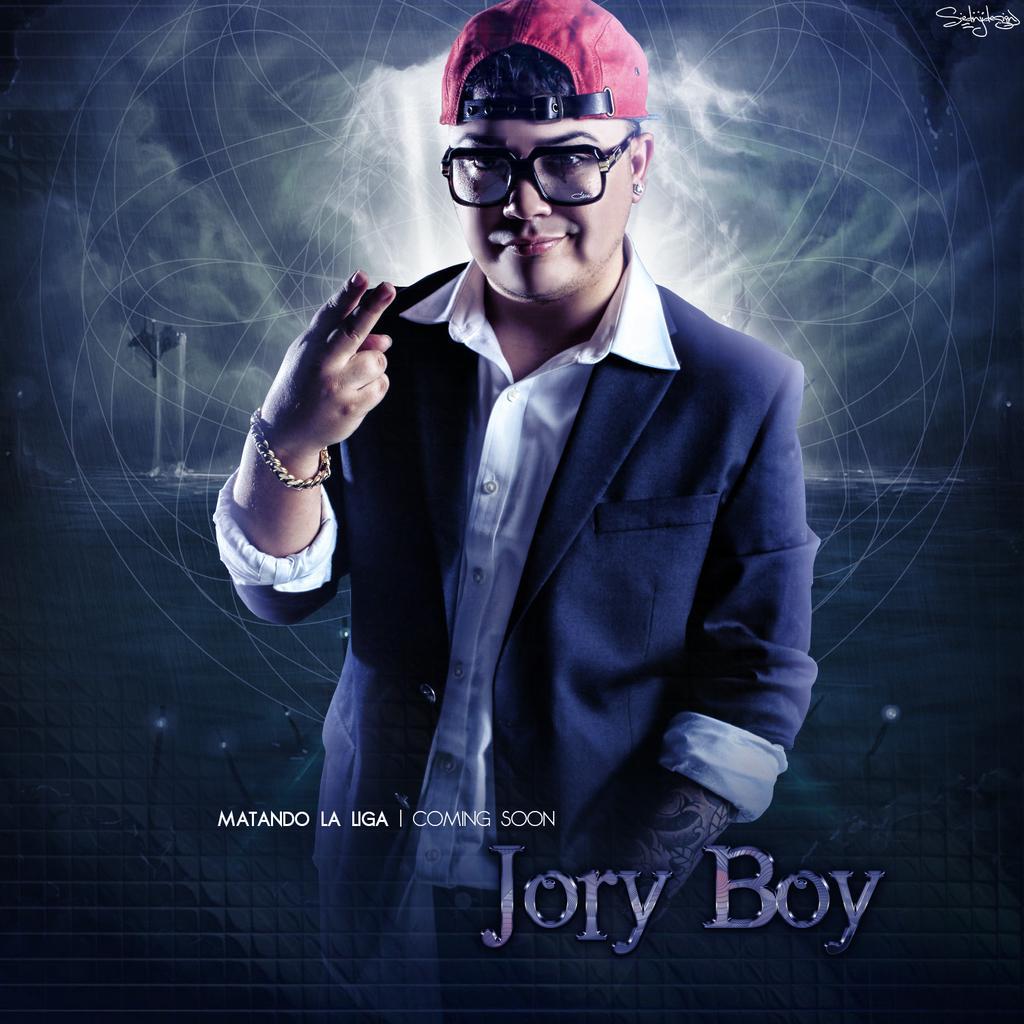In one or two sentences, can you explain what this image depicts? In the foreground I can see a person and a text. In the background I can see a wall and boats in the water. This image is taken during night. 